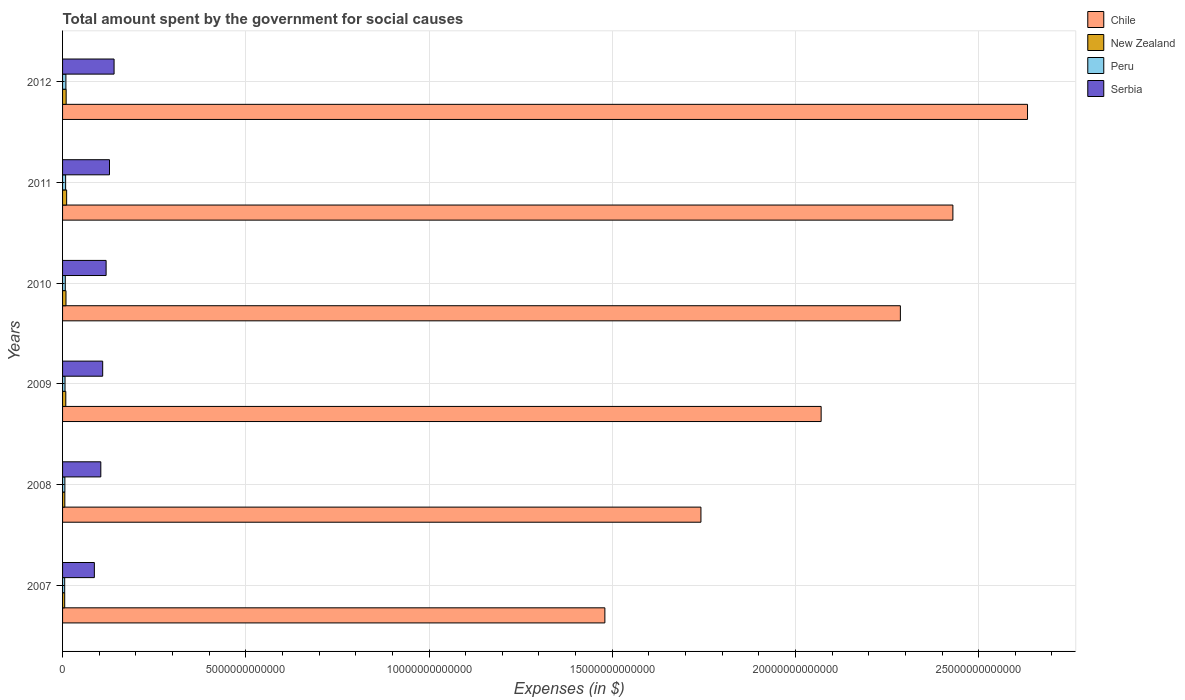How many groups of bars are there?
Ensure brevity in your answer.  6. Are the number of bars per tick equal to the number of legend labels?
Give a very brief answer. Yes. Are the number of bars on each tick of the Y-axis equal?
Your answer should be compact. Yes. How many bars are there on the 5th tick from the bottom?
Your response must be concise. 4. In how many cases, is the number of bars for a given year not equal to the number of legend labels?
Ensure brevity in your answer.  0. What is the amount spent for social causes by the government in New Zealand in 2009?
Make the answer very short. 8.84e+1. Across all years, what is the maximum amount spent for social causes by the government in New Zealand?
Keep it short and to the point. 1.11e+11. Across all years, what is the minimum amount spent for social causes by the government in Serbia?
Provide a succinct answer. 8.68e+11. In which year was the amount spent for social causes by the government in Chile minimum?
Your answer should be compact. 2007. What is the total amount spent for social causes by the government in New Zealand in the graph?
Your answer should be very brief. 5.11e+11. What is the difference between the amount spent for social causes by the government in Chile in 2009 and that in 2012?
Offer a terse response. -5.63e+12. What is the difference between the amount spent for social causes by the government in Serbia in 2009 and the amount spent for social causes by the government in Peru in 2007?
Offer a terse response. 1.04e+12. What is the average amount spent for social causes by the government in Peru per year?
Make the answer very short. 7.28e+1. In the year 2012, what is the difference between the amount spent for social causes by the government in Chile and amount spent for social causes by the government in Serbia?
Provide a succinct answer. 2.49e+13. What is the ratio of the amount spent for social causes by the government in Chile in 2007 to that in 2012?
Give a very brief answer. 0.56. Is the amount spent for social causes by the government in Peru in 2007 less than that in 2011?
Your response must be concise. Yes. What is the difference between the highest and the second highest amount spent for social causes by the government in Peru?
Give a very brief answer. 7.68e+09. What is the difference between the highest and the lowest amount spent for social causes by the government in Chile?
Your answer should be compact. 1.15e+13. In how many years, is the amount spent for social causes by the government in Chile greater than the average amount spent for social causes by the government in Chile taken over all years?
Provide a short and direct response. 3. Is it the case that in every year, the sum of the amount spent for social causes by the government in Chile and amount spent for social causes by the government in New Zealand is greater than the sum of amount spent for social causes by the government in Serbia and amount spent for social causes by the government in Peru?
Keep it short and to the point. Yes. Are all the bars in the graph horizontal?
Your answer should be very brief. Yes. How many years are there in the graph?
Your response must be concise. 6. What is the difference between two consecutive major ticks on the X-axis?
Make the answer very short. 5.00e+12. Does the graph contain grids?
Give a very brief answer. Yes. How are the legend labels stacked?
Provide a succinct answer. Vertical. What is the title of the graph?
Offer a terse response. Total amount spent by the government for social causes. What is the label or title of the X-axis?
Provide a short and direct response. Expenses (in $). What is the label or title of the Y-axis?
Your answer should be compact. Years. What is the Expenses (in $) in Chile in 2007?
Your answer should be compact. 1.48e+13. What is the Expenses (in $) of New Zealand in 2007?
Ensure brevity in your answer.  5.84e+1. What is the Expenses (in $) of Peru in 2007?
Provide a short and direct response. 5.80e+1. What is the Expenses (in $) of Serbia in 2007?
Keep it short and to the point. 8.68e+11. What is the Expenses (in $) of Chile in 2008?
Your response must be concise. 1.74e+13. What is the Expenses (in $) in New Zealand in 2008?
Your answer should be very brief. 6.18e+1. What is the Expenses (in $) of Peru in 2008?
Offer a very short reply. 6.29e+1. What is the Expenses (in $) of Serbia in 2008?
Offer a very short reply. 1.04e+12. What is the Expenses (in $) in Chile in 2009?
Your answer should be very brief. 2.07e+13. What is the Expenses (in $) of New Zealand in 2009?
Give a very brief answer. 8.84e+1. What is the Expenses (in $) in Peru in 2009?
Offer a very short reply. 6.73e+1. What is the Expenses (in $) in Serbia in 2009?
Provide a short and direct response. 1.10e+12. What is the Expenses (in $) in Chile in 2010?
Your answer should be compact. 2.29e+13. What is the Expenses (in $) of New Zealand in 2010?
Your response must be concise. 9.33e+1. What is the Expenses (in $) in Peru in 2010?
Keep it short and to the point. 7.43e+1. What is the Expenses (in $) in Serbia in 2010?
Your answer should be very brief. 1.19e+12. What is the Expenses (in $) in Chile in 2011?
Your response must be concise. 2.43e+13. What is the Expenses (in $) in New Zealand in 2011?
Make the answer very short. 1.11e+11. What is the Expenses (in $) of Peru in 2011?
Your answer should be compact. 8.34e+1. What is the Expenses (in $) in Serbia in 2011?
Offer a very short reply. 1.28e+12. What is the Expenses (in $) of Chile in 2012?
Provide a short and direct response. 2.63e+13. What is the Expenses (in $) in New Zealand in 2012?
Provide a succinct answer. 9.80e+1. What is the Expenses (in $) in Peru in 2012?
Your answer should be very brief. 9.11e+1. What is the Expenses (in $) of Serbia in 2012?
Give a very brief answer. 1.41e+12. Across all years, what is the maximum Expenses (in $) of Chile?
Provide a short and direct response. 2.63e+13. Across all years, what is the maximum Expenses (in $) in New Zealand?
Your answer should be compact. 1.11e+11. Across all years, what is the maximum Expenses (in $) in Peru?
Make the answer very short. 9.11e+1. Across all years, what is the maximum Expenses (in $) in Serbia?
Your answer should be very brief. 1.41e+12. Across all years, what is the minimum Expenses (in $) of Chile?
Your answer should be compact. 1.48e+13. Across all years, what is the minimum Expenses (in $) of New Zealand?
Provide a succinct answer. 5.84e+1. Across all years, what is the minimum Expenses (in $) of Peru?
Keep it short and to the point. 5.80e+1. Across all years, what is the minimum Expenses (in $) in Serbia?
Give a very brief answer. 8.68e+11. What is the total Expenses (in $) in Chile in the graph?
Your answer should be compact. 1.26e+14. What is the total Expenses (in $) of New Zealand in the graph?
Your answer should be compact. 5.11e+11. What is the total Expenses (in $) in Peru in the graph?
Provide a succinct answer. 4.37e+11. What is the total Expenses (in $) of Serbia in the graph?
Give a very brief answer. 6.88e+12. What is the difference between the Expenses (in $) in Chile in 2007 and that in 2008?
Provide a short and direct response. -2.62e+12. What is the difference between the Expenses (in $) in New Zealand in 2007 and that in 2008?
Your answer should be very brief. -3.37e+09. What is the difference between the Expenses (in $) of Peru in 2007 and that in 2008?
Provide a short and direct response. -4.86e+09. What is the difference between the Expenses (in $) in Serbia in 2007 and that in 2008?
Keep it short and to the point. -1.76e+11. What is the difference between the Expenses (in $) in Chile in 2007 and that in 2009?
Give a very brief answer. -5.90e+12. What is the difference between the Expenses (in $) in New Zealand in 2007 and that in 2009?
Ensure brevity in your answer.  -2.99e+1. What is the difference between the Expenses (in $) of Peru in 2007 and that in 2009?
Offer a terse response. -9.27e+09. What is the difference between the Expenses (in $) of Serbia in 2007 and that in 2009?
Provide a short and direct response. -2.27e+11. What is the difference between the Expenses (in $) in Chile in 2007 and that in 2010?
Provide a short and direct response. -8.06e+12. What is the difference between the Expenses (in $) of New Zealand in 2007 and that in 2010?
Give a very brief answer. -3.48e+1. What is the difference between the Expenses (in $) of Peru in 2007 and that in 2010?
Offer a terse response. -1.63e+1. What is the difference between the Expenses (in $) of Serbia in 2007 and that in 2010?
Your answer should be compact. -3.21e+11. What is the difference between the Expenses (in $) of Chile in 2007 and that in 2011?
Ensure brevity in your answer.  -9.50e+12. What is the difference between the Expenses (in $) in New Zealand in 2007 and that in 2011?
Your answer should be compact. -5.26e+1. What is the difference between the Expenses (in $) in Peru in 2007 and that in 2011?
Offer a terse response. -2.54e+1. What is the difference between the Expenses (in $) in Serbia in 2007 and that in 2011?
Give a very brief answer. -4.13e+11. What is the difference between the Expenses (in $) in Chile in 2007 and that in 2012?
Provide a short and direct response. -1.15e+13. What is the difference between the Expenses (in $) of New Zealand in 2007 and that in 2012?
Offer a very short reply. -3.96e+1. What is the difference between the Expenses (in $) of Peru in 2007 and that in 2012?
Your response must be concise. -3.31e+1. What is the difference between the Expenses (in $) of Serbia in 2007 and that in 2012?
Keep it short and to the point. -5.38e+11. What is the difference between the Expenses (in $) in Chile in 2008 and that in 2009?
Your response must be concise. -3.28e+12. What is the difference between the Expenses (in $) of New Zealand in 2008 and that in 2009?
Offer a terse response. -2.65e+1. What is the difference between the Expenses (in $) in Peru in 2008 and that in 2009?
Offer a terse response. -4.41e+09. What is the difference between the Expenses (in $) in Serbia in 2008 and that in 2009?
Give a very brief answer. -5.15e+1. What is the difference between the Expenses (in $) in Chile in 2008 and that in 2010?
Make the answer very short. -5.44e+12. What is the difference between the Expenses (in $) of New Zealand in 2008 and that in 2010?
Your answer should be very brief. -3.15e+1. What is the difference between the Expenses (in $) of Peru in 2008 and that in 2010?
Your answer should be compact. -1.14e+1. What is the difference between the Expenses (in $) of Serbia in 2008 and that in 2010?
Give a very brief answer. -1.45e+11. What is the difference between the Expenses (in $) in Chile in 2008 and that in 2011?
Make the answer very short. -6.88e+12. What is the difference between the Expenses (in $) in New Zealand in 2008 and that in 2011?
Make the answer very short. -4.92e+1. What is the difference between the Expenses (in $) of Peru in 2008 and that in 2011?
Provide a succinct answer. -2.05e+1. What is the difference between the Expenses (in $) of Serbia in 2008 and that in 2011?
Give a very brief answer. -2.37e+11. What is the difference between the Expenses (in $) in Chile in 2008 and that in 2012?
Ensure brevity in your answer.  -8.91e+12. What is the difference between the Expenses (in $) in New Zealand in 2008 and that in 2012?
Your response must be concise. -3.62e+1. What is the difference between the Expenses (in $) of Peru in 2008 and that in 2012?
Your answer should be very brief. -2.82e+1. What is the difference between the Expenses (in $) in Serbia in 2008 and that in 2012?
Ensure brevity in your answer.  -3.62e+11. What is the difference between the Expenses (in $) in Chile in 2009 and that in 2010?
Your answer should be compact. -2.16e+12. What is the difference between the Expenses (in $) of New Zealand in 2009 and that in 2010?
Provide a short and direct response. -4.93e+09. What is the difference between the Expenses (in $) of Peru in 2009 and that in 2010?
Ensure brevity in your answer.  -7.01e+09. What is the difference between the Expenses (in $) of Serbia in 2009 and that in 2010?
Provide a succinct answer. -9.34e+1. What is the difference between the Expenses (in $) of Chile in 2009 and that in 2011?
Provide a succinct answer. -3.60e+12. What is the difference between the Expenses (in $) in New Zealand in 2009 and that in 2011?
Make the answer very short. -2.27e+1. What is the difference between the Expenses (in $) of Peru in 2009 and that in 2011?
Offer a terse response. -1.61e+1. What is the difference between the Expenses (in $) of Serbia in 2009 and that in 2011?
Give a very brief answer. -1.86e+11. What is the difference between the Expenses (in $) of Chile in 2009 and that in 2012?
Give a very brief answer. -5.63e+12. What is the difference between the Expenses (in $) of New Zealand in 2009 and that in 2012?
Offer a terse response. -9.65e+09. What is the difference between the Expenses (in $) of Peru in 2009 and that in 2012?
Ensure brevity in your answer.  -2.38e+1. What is the difference between the Expenses (in $) of Serbia in 2009 and that in 2012?
Provide a short and direct response. -3.11e+11. What is the difference between the Expenses (in $) of Chile in 2010 and that in 2011?
Give a very brief answer. -1.43e+12. What is the difference between the Expenses (in $) of New Zealand in 2010 and that in 2011?
Offer a terse response. -1.77e+1. What is the difference between the Expenses (in $) in Peru in 2010 and that in 2011?
Your answer should be compact. -9.12e+09. What is the difference between the Expenses (in $) in Serbia in 2010 and that in 2011?
Provide a succinct answer. -9.25e+1. What is the difference between the Expenses (in $) of Chile in 2010 and that in 2012?
Offer a very short reply. -3.47e+12. What is the difference between the Expenses (in $) of New Zealand in 2010 and that in 2012?
Provide a short and direct response. -4.72e+09. What is the difference between the Expenses (in $) in Peru in 2010 and that in 2012?
Give a very brief answer. -1.68e+1. What is the difference between the Expenses (in $) in Serbia in 2010 and that in 2012?
Offer a very short reply. -2.17e+11. What is the difference between the Expenses (in $) in Chile in 2011 and that in 2012?
Your response must be concise. -2.04e+12. What is the difference between the Expenses (in $) of New Zealand in 2011 and that in 2012?
Make the answer very short. 1.30e+1. What is the difference between the Expenses (in $) of Peru in 2011 and that in 2012?
Offer a very short reply. -7.68e+09. What is the difference between the Expenses (in $) of Serbia in 2011 and that in 2012?
Keep it short and to the point. -1.25e+11. What is the difference between the Expenses (in $) in Chile in 2007 and the Expenses (in $) in New Zealand in 2008?
Provide a short and direct response. 1.47e+13. What is the difference between the Expenses (in $) in Chile in 2007 and the Expenses (in $) in Peru in 2008?
Ensure brevity in your answer.  1.47e+13. What is the difference between the Expenses (in $) of Chile in 2007 and the Expenses (in $) of Serbia in 2008?
Make the answer very short. 1.38e+13. What is the difference between the Expenses (in $) in New Zealand in 2007 and the Expenses (in $) in Peru in 2008?
Give a very brief answer. -4.42e+09. What is the difference between the Expenses (in $) of New Zealand in 2007 and the Expenses (in $) of Serbia in 2008?
Provide a succinct answer. -9.85e+11. What is the difference between the Expenses (in $) of Peru in 2007 and the Expenses (in $) of Serbia in 2008?
Your answer should be very brief. -9.86e+11. What is the difference between the Expenses (in $) of Chile in 2007 and the Expenses (in $) of New Zealand in 2009?
Your response must be concise. 1.47e+13. What is the difference between the Expenses (in $) in Chile in 2007 and the Expenses (in $) in Peru in 2009?
Provide a succinct answer. 1.47e+13. What is the difference between the Expenses (in $) in Chile in 2007 and the Expenses (in $) in Serbia in 2009?
Your answer should be compact. 1.37e+13. What is the difference between the Expenses (in $) in New Zealand in 2007 and the Expenses (in $) in Peru in 2009?
Your answer should be compact. -8.82e+09. What is the difference between the Expenses (in $) in New Zealand in 2007 and the Expenses (in $) in Serbia in 2009?
Give a very brief answer. -1.04e+12. What is the difference between the Expenses (in $) of Peru in 2007 and the Expenses (in $) of Serbia in 2009?
Make the answer very short. -1.04e+12. What is the difference between the Expenses (in $) of Chile in 2007 and the Expenses (in $) of New Zealand in 2010?
Your answer should be very brief. 1.47e+13. What is the difference between the Expenses (in $) of Chile in 2007 and the Expenses (in $) of Peru in 2010?
Ensure brevity in your answer.  1.47e+13. What is the difference between the Expenses (in $) of Chile in 2007 and the Expenses (in $) of Serbia in 2010?
Offer a terse response. 1.36e+13. What is the difference between the Expenses (in $) of New Zealand in 2007 and the Expenses (in $) of Peru in 2010?
Offer a terse response. -1.58e+1. What is the difference between the Expenses (in $) of New Zealand in 2007 and the Expenses (in $) of Serbia in 2010?
Your answer should be very brief. -1.13e+12. What is the difference between the Expenses (in $) in Peru in 2007 and the Expenses (in $) in Serbia in 2010?
Offer a very short reply. -1.13e+12. What is the difference between the Expenses (in $) in Chile in 2007 and the Expenses (in $) in New Zealand in 2011?
Make the answer very short. 1.47e+13. What is the difference between the Expenses (in $) in Chile in 2007 and the Expenses (in $) in Peru in 2011?
Make the answer very short. 1.47e+13. What is the difference between the Expenses (in $) in Chile in 2007 and the Expenses (in $) in Serbia in 2011?
Keep it short and to the point. 1.35e+13. What is the difference between the Expenses (in $) in New Zealand in 2007 and the Expenses (in $) in Peru in 2011?
Your answer should be very brief. -2.50e+1. What is the difference between the Expenses (in $) of New Zealand in 2007 and the Expenses (in $) of Serbia in 2011?
Your response must be concise. -1.22e+12. What is the difference between the Expenses (in $) in Peru in 2007 and the Expenses (in $) in Serbia in 2011?
Provide a short and direct response. -1.22e+12. What is the difference between the Expenses (in $) in Chile in 2007 and the Expenses (in $) in New Zealand in 2012?
Your response must be concise. 1.47e+13. What is the difference between the Expenses (in $) of Chile in 2007 and the Expenses (in $) of Peru in 2012?
Your answer should be compact. 1.47e+13. What is the difference between the Expenses (in $) in Chile in 2007 and the Expenses (in $) in Serbia in 2012?
Offer a very short reply. 1.34e+13. What is the difference between the Expenses (in $) of New Zealand in 2007 and the Expenses (in $) of Peru in 2012?
Offer a terse response. -3.26e+1. What is the difference between the Expenses (in $) in New Zealand in 2007 and the Expenses (in $) in Serbia in 2012?
Your answer should be compact. -1.35e+12. What is the difference between the Expenses (in $) in Peru in 2007 and the Expenses (in $) in Serbia in 2012?
Give a very brief answer. -1.35e+12. What is the difference between the Expenses (in $) of Chile in 2008 and the Expenses (in $) of New Zealand in 2009?
Offer a terse response. 1.73e+13. What is the difference between the Expenses (in $) of Chile in 2008 and the Expenses (in $) of Peru in 2009?
Your answer should be very brief. 1.74e+13. What is the difference between the Expenses (in $) in Chile in 2008 and the Expenses (in $) in Serbia in 2009?
Offer a very short reply. 1.63e+13. What is the difference between the Expenses (in $) in New Zealand in 2008 and the Expenses (in $) in Peru in 2009?
Make the answer very short. -5.46e+09. What is the difference between the Expenses (in $) in New Zealand in 2008 and the Expenses (in $) in Serbia in 2009?
Provide a succinct answer. -1.03e+12. What is the difference between the Expenses (in $) in Peru in 2008 and the Expenses (in $) in Serbia in 2009?
Ensure brevity in your answer.  -1.03e+12. What is the difference between the Expenses (in $) of Chile in 2008 and the Expenses (in $) of New Zealand in 2010?
Ensure brevity in your answer.  1.73e+13. What is the difference between the Expenses (in $) in Chile in 2008 and the Expenses (in $) in Peru in 2010?
Your answer should be compact. 1.73e+13. What is the difference between the Expenses (in $) in Chile in 2008 and the Expenses (in $) in Serbia in 2010?
Offer a very short reply. 1.62e+13. What is the difference between the Expenses (in $) of New Zealand in 2008 and the Expenses (in $) of Peru in 2010?
Provide a succinct answer. -1.25e+1. What is the difference between the Expenses (in $) of New Zealand in 2008 and the Expenses (in $) of Serbia in 2010?
Your answer should be compact. -1.13e+12. What is the difference between the Expenses (in $) of Peru in 2008 and the Expenses (in $) of Serbia in 2010?
Your response must be concise. -1.13e+12. What is the difference between the Expenses (in $) in Chile in 2008 and the Expenses (in $) in New Zealand in 2011?
Provide a short and direct response. 1.73e+13. What is the difference between the Expenses (in $) of Chile in 2008 and the Expenses (in $) of Peru in 2011?
Your answer should be very brief. 1.73e+13. What is the difference between the Expenses (in $) of Chile in 2008 and the Expenses (in $) of Serbia in 2011?
Offer a terse response. 1.61e+13. What is the difference between the Expenses (in $) of New Zealand in 2008 and the Expenses (in $) of Peru in 2011?
Provide a succinct answer. -2.16e+1. What is the difference between the Expenses (in $) of New Zealand in 2008 and the Expenses (in $) of Serbia in 2011?
Ensure brevity in your answer.  -1.22e+12. What is the difference between the Expenses (in $) of Peru in 2008 and the Expenses (in $) of Serbia in 2011?
Your answer should be compact. -1.22e+12. What is the difference between the Expenses (in $) of Chile in 2008 and the Expenses (in $) of New Zealand in 2012?
Provide a short and direct response. 1.73e+13. What is the difference between the Expenses (in $) in Chile in 2008 and the Expenses (in $) in Peru in 2012?
Give a very brief answer. 1.73e+13. What is the difference between the Expenses (in $) of Chile in 2008 and the Expenses (in $) of Serbia in 2012?
Ensure brevity in your answer.  1.60e+13. What is the difference between the Expenses (in $) of New Zealand in 2008 and the Expenses (in $) of Peru in 2012?
Offer a very short reply. -2.93e+1. What is the difference between the Expenses (in $) of New Zealand in 2008 and the Expenses (in $) of Serbia in 2012?
Your answer should be compact. -1.34e+12. What is the difference between the Expenses (in $) of Peru in 2008 and the Expenses (in $) of Serbia in 2012?
Keep it short and to the point. -1.34e+12. What is the difference between the Expenses (in $) in Chile in 2009 and the Expenses (in $) in New Zealand in 2010?
Provide a succinct answer. 2.06e+13. What is the difference between the Expenses (in $) in Chile in 2009 and the Expenses (in $) in Peru in 2010?
Your answer should be very brief. 2.06e+13. What is the difference between the Expenses (in $) in Chile in 2009 and the Expenses (in $) in Serbia in 2010?
Make the answer very short. 1.95e+13. What is the difference between the Expenses (in $) in New Zealand in 2009 and the Expenses (in $) in Peru in 2010?
Your response must be concise. 1.41e+1. What is the difference between the Expenses (in $) of New Zealand in 2009 and the Expenses (in $) of Serbia in 2010?
Offer a terse response. -1.10e+12. What is the difference between the Expenses (in $) of Peru in 2009 and the Expenses (in $) of Serbia in 2010?
Provide a succinct answer. -1.12e+12. What is the difference between the Expenses (in $) of Chile in 2009 and the Expenses (in $) of New Zealand in 2011?
Ensure brevity in your answer.  2.06e+13. What is the difference between the Expenses (in $) of Chile in 2009 and the Expenses (in $) of Peru in 2011?
Your response must be concise. 2.06e+13. What is the difference between the Expenses (in $) in Chile in 2009 and the Expenses (in $) in Serbia in 2011?
Provide a short and direct response. 1.94e+13. What is the difference between the Expenses (in $) in New Zealand in 2009 and the Expenses (in $) in Peru in 2011?
Your response must be concise. 4.96e+09. What is the difference between the Expenses (in $) of New Zealand in 2009 and the Expenses (in $) of Serbia in 2011?
Offer a terse response. -1.19e+12. What is the difference between the Expenses (in $) in Peru in 2009 and the Expenses (in $) in Serbia in 2011?
Your answer should be very brief. -1.21e+12. What is the difference between the Expenses (in $) in Chile in 2009 and the Expenses (in $) in New Zealand in 2012?
Keep it short and to the point. 2.06e+13. What is the difference between the Expenses (in $) of Chile in 2009 and the Expenses (in $) of Peru in 2012?
Keep it short and to the point. 2.06e+13. What is the difference between the Expenses (in $) of Chile in 2009 and the Expenses (in $) of Serbia in 2012?
Offer a terse response. 1.93e+13. What is the difference between the Expenses (in $) of New Zealand in 2009 and the Expenses (in $) of Peru in 2012?
Your answer should be very brief. -2.73e+09. What is the difference between the Expenses (in $) of New Zealand in 2009 and the Expenses (in $) of Serbia in 2012?
Provide a short and direct response. -1.32e+12. What is the difference between the Expenses (in $) in Peru in 2009 and the Expenses (in $) in Serbia in 2012?
Keep it short and to the point. -1.34e+12. What is the difference between the Expenses (in $) of Chile in 2010 and the Expenses (in $) of New Zealand in 2011?
Offer a terse response. 2.28e+13. What is the difference between the Expenses (in $) of Chile in 2010 and the Expenses (in $) of Peru in 2011?
Your answer should be very brief. 2.28e+13. What is the difference between the Expenses (in $) in Chile in 2010 and the Expenses (in $) in Serbia in 2011?
Give a very brief answer. 2.16e+13. What is the difference between the Expenses (in $) in New Zealand in 2010 and the Expenses (in $) in Peru in 2011?
Offer a very short reply. 9.89e+09. What is the difference between the Expenses (in $) of New Zealand in 2010 and the Expenses (in $) of Serbia in 2011?
Offer a very short reply. -1.19e+12. What is the difference between the Expenses (in $) in Peru in 2010 and the Expenses (in $) in Serbia in 2011?
Make the answer very short. -1.21e+12. What is the difference between the Expenses (in $) in Chile in 2010 and the Expenses (in $) in New Zealand in 2012?
Make the answer very short. 2.28e+13. What is the difference between the Expenses (in $) of Chile in 2010 and the Expenses (in $) of Peru in 2012?
Your answer should be very brief. 2.28e+13. What is the difference between the Expenses (in $) in Chile in 2010 and the Expenses (in $) in Serbia in 2012?
Your answer should be compact. 2.15e+13. What is the difference between the Expenses (in $) of New Zealand in 2010 and the Expenses (in $) of Peru in 2012?
Provide a short and direct response. 2.20e+09. What is the difference between the Expenses (in $) in New Zealand in 2010 and the Expenses (in $) in Serbia in 2012?
Keep it short and to the point. -1.31e+12. What is the difference between the Expenses (in $) in Peru in 2010 and the Expenses (in $) in Serbia in 2012?
Your answer should be very brief. -1.33e+12. What is the difference between the Expenses (in $) of Chile in 2011 and the Expenses (in $) of New Zealand in 2012?
Your answer should be very brief. 2.42e+13. What is the difference between the Expenses (in $) in Chile in 2011 and the Expenses (in $) in Peru in 2012?
Keep it short and to the point. 2.42e+13. What is the difference between the Expenses (in $) of Chile in 2011 and the Expenses (in $) of Serbia in 2012?
Your response must be concise. 2.29e+13. What is the difference between the Expenses (in $) of New Zealand in 2011 and the Expenses (in $) of Peru in 2012?
Your answer should be compact. 1.99e+1. What is the difference between the Expenses (in $) of New Zealand in 2011 and the Expenses (in $) of Serbia in 2012?
Ensure brevity in your answer.  -1.29e+12. What is the difference between the Expenses (in $) in Peru in 2011 and the Expenses (in $) in Serbia in 2012?
Make the answer very short. -1.32e+12. What is the average Expenses (in $) of Chile per year?
Ensure brevity in your answer.  2.11e+13. What is the average Expenses (in $) in New Zealand per year?
Ensure brevity in your answer.  8.52e+1. What is the average Expenses (in $) of Peru per year?
Your answer should be very brief. 7.28e+1. What is the average Expenses (in $) in Serbia per year?
Make the answer very short. 1.15e+12. In the year 2007, what is the difference between the Expenses (in $) in Chile and Expenses (in $) in New Zealand?
Make the answer very short. 1.47e+13. In the year 2007, what is the difference between the Expenses (in $) in Chile and Expenses (in $) in Peru?
Ensure brevity in your answer.  1.47e+13. In the year 2007, what is the difference between the Expenses (in $) in Chile and Expenses (in $) in Serbia?
Offer a very short reply. 1.39e+13. In the year 2007, what is the difference between the Expenses (in $) in New Zealand and Expenses (in $) in Peru?
Give a very brief answer. 4.45e+08. In the year 2007, what is the difference between the Expenses (in $) of New Zealand and Expenses (in $) of Serbia?
Provide a short and direct response. -8.09e+11. In the year 2007, what is the difference between the Expenses (in $) of Peru and Expenses (in $) of Serbia?
Provide a succinct answer. -8.10e+11. In the year 2008, what is the difference between the Expenses (in $) in Chile and Expenses (in $) in New Zealand?
Your response must be concise. 1.74e+13. In the year 2008, what is the difference between the Expenses (in $) in Chile and Expenses (in $) in Peru?
Provide a short and direct response. 1.74e+13. In the year 2008, what is the difference between the Expenses (in $) in Chile and Expenses (in $) in Serbia?
Ensure brevity in your answer.  1.64e+13. In the year 2008, what is the difference between the Expenses (in $) in New Zealand and Expenses (in $) in Peru?
Your answer should be compact. -1.05e+09. In the year 2008, what is the difference between the Expenses (in $) of New Zealand and Expenses (in $) of Serbia?
Your response must be concise. -9.82e+11. In the year 2008, what is the difference between the Expenses (in $) in Peru and Expenses (in $) in Serbia?
Keep it short and to the point. -9.81e+11. In the year 2009, what is the difference between the Expenses (in $) in Chile and Expenses (in $) in New Zealand?
Keep it short and to the point. 2.06e+13. In the year 2009, what is the difference between the Expenses (in $) in Chile and Expenses (in $) in Peru?
Provide a short and direct response. 2.06e+13. In the year 2009, what is the difference between the Expenses (in $) of Chile and Expenses (in $) of Serbia?
Provide a short and direct response. 1.96e+13. In the year 2009, what is the difference between the Expenses (in $) of New Zealand and Expenses (in $) of Peru?
Give a very brief answer. 2.11e+1. In the year 2009, what is the difference between the Expenses (in $) in New Zealand and Expenses (in $) in Serbia?
Provide a short and direct response. -1.01e+12. In the year 2009, what is the difference between the Expenses (in $) of Peru and Expenses (in $) of Serbia?
Make the answer very short. -1.03e+12. In the year 2010, what is the difference between the Expenses (in $) of Chile and Expenses (in $) of New Zealand?
Provide a short and direct response. 2.28e+13. In the year 2010, what is the difference between the Expenses (in $) of Chile and Expenses (in $) of Peru?
Your response must be concise. 2.28e+13. In the year 2010, what is the difference between the Expenses (in $) in Chile and Expenses (in $) in Serbia?
Your answer should be compact. 2.17e+13. In the year 2010, what is the difference between the Expenses (in $) of New Zealand and Expenses (in $) of Peru?
Give a very brief answer. 1.90e+1. In the year 2010, what is the difference between the Expenses (in $) in New Zealand and Expenses (in $) in Serbia?
Keep it short and to the point. -1.10e+12. In the year 2010, what is the difference between the Expenses (in $) in Peru and Expenses (in $) in Serbia?
Make the answer very short. -1.11e+12. In the year 2011, what is the difference between the Expenses (in $) of Chile and Expenses (in $) of New Zealand?
Your response must be concise. 2.42e+13. In the year 2011, what is the difference between the Expenses (in $) of Chile and Expenses (in $) of Peru?
Ensure brevity in your answer.  2.42e+13. In the year 2011, what is the difference between the Expenses (in $) in Chile and Expenses (in $) in Serbia?
Your response must be concise. 2.30e+13. In the year 2011, what is the difference between the Expenses (in $) of New Zealand and Expenses (in $) of Peru?
Your answer should be compact. 2.76e+1. In the year 2011, what is the difference between the Expenses (in $) of New Zealand and Expenses (in $) of Serbia?
Offer a terse response. -1.17e+12. In the year 2011, what is the difference between the Expenses (in $) in Peru and Expenses (in $) in Serbia?
Your response must be concise. -1.20e+12. In the year 2012, what is the difference between the Expenses (in $) in Chile and Expenses (in $) in New Zealand?
Give a very brief answer. 2.62e+13. In the year 2012, what is the difference between the Expenses (in $) of Chile and Expenses (in $) of Peru?
Your response must be concise. 2.62e+13. In the year 2012, what is the difference between the Expenses (in $) of Chile and Expenses (in $) of Serbia?
Offer a terse response. 2.49e+13. In the year 2012, what is the difference between the Expenses (in $) in New Zealand and Expenses (in $) in Peru?
Your answer should be compact. 6.93e+09. In the year 2012, what is the difference between the Expenses (in $) of New Zealand and Expenses (in $) of Serbia?
Your answer should be compact. -1.31e+12. In the year 2012, what is the difference between the Expenses (in $) in Peru and Expenses (in $) in Serbia?
Your answer should be compact. -1.31e+12. What is the ratio of the Expenses (in $) in Chile in 2007 to that in 2008?
Your answer should be very brief. 0.85. What is the ratio of the Expenses (in $) in New Zealand in 2007 to that in 2008?
Your answer should be compact. 0.95. What is the ratio of the Expenses (in $) in Peru in 2007 to that in 2008?
Make the answer very short. 0.92. What is the ratio of the Expenses (in $) in Serbia in 2007 to that in 2008?
Offer a very short reply. 0.83. What is the ratio of the Expenses (in $) of Chile in 2007 to that in 2009?
Offer a very short reply. 0.71. What is the ratio of the Expenses (in $) of New Zealand in 2007 to that in 2009?
Your answer should be compact. 0.66. What is the ratio of the Expenses (in $) in Peru in 2007 to that in 2009?
Make the answer very short. 0.86. What is the ratio of the Expenses (in $) of Serbia in 2007 to that in 2009?
Your answer should be very brief. 0.79. What is the ratio of the Expenses (in $) of Chile in 2007 to that in 2010?
Provide a short and direct response. 0.65. What is the ratio of the Expenses (in $) in New Zealand in 2007 to that in 2010?
Offer a very short reply. 0.63. What is the ratio of the Expenses (in $) in Peru in 2007 to that in 2010?
Your answer should be compact. 0.78. What is the ratio of the Expenses (in $) of Serbia in 2007 to that in 2010?
Offer a very short reply. 0.73. What is the ratio of the Expenses (in $) of Chile in 2007 to that in 2011?
Provide a short and direct response. 0.61. What is the ratio of the Expenses (in $) of New Zealand in 2007 to that in 2011?
Your answer should be compact. 0.53. What is the ratio of the Expenses (in $) of Peru in 2007 to that in 2011?
Give a very brief answer. 0.7. What is the ratio of the Expenses (in $) in Serbia in 2007 to that in 2011?
Offer a terse response. 0.68. What is the ratio of the Expenses (in $) in Chile in 2007 to that in 2012?
Your answer should be very brief. 0.56. What is the ratio of the Expenses (in $) of New Zealand in 2007 to that in 2012?
Your response must be concise. 0.6. What is the ratio of the Expenses (in $) in Peru in 2007 to that in 2012?
Provide a short and direct response. 0.64. What is the ratio of the Expenses (in $) of Serbia in 2007 to that in 2012?
Offer a very short reply. 0.62. What is the ratio of the Expenses (in $) of Chile in 2008 to that in 2009?
Your answer should be compact. 0.84. What is the ratio of the Expenses (in $) in New Zealand in 2008 to that in 2009?
Your response must be concise. 0.7. What is the ratio of the Expenses (in $) of Peru in 2008 to that in 2009?
Your answer should be very brief. 0.93. What is the ratio of the Expenses (in $) in Serbia in 2008 to that in 2009?
Your answer should be compact. 0.95. What is the ratio of the Expenses (in $) in Chile in 2008 to that in 2010?
Keep it short and to the point. 0.76. What is the ratio of the Expenses (in $) in New Zealand in 2008 to that in 2010?
Give a very brief answer. 0.66. What is the ratio of the Expenses (in $) of Peru in 2008 to that in 2010?
Keep it short and to the point. 0.85. What is the ratio of the Expenses (in $) in Serbia in 2008 to that in 2010?
Offer a very short reply. 0.88. What is the ratio of the Expenses (in $) of Chile in 2008 to that in 2011?
Provide a short and direct response. 0.72. What is the ratio of the Expenses (in $) of New Zealand in 2008 to that in 2011?
Offer a very short reply. 0.56. What is the ratio of the Expenses (in $) of Peru in 2008 to that in 2011?
Ensure brevity in your answer.  0.75. What is the ratio of the Expenses (in $) in Serbia in 2008 to that in 2011?
Give a very brief answer. 0.81. What is the ratio of the Expenses (in $) in Chile in 2008 to that in 2012?
Provide a short and direct response. 0.66. What is the ratio of the Expenses (in $) of New Zealand in 2008 to that in 2012?
Give a very brief answer. 0.63. What is the ratio of the Expenses (in $) of Peru in 2008 to that in 2012?
Make the answer very short. 0.69. What is the ratio of the Expenses (in $) of Serbia in 2008 to that in 2012?
Make the answer very short. 0.74. What is the ratio of the Expenses (in $) of Chile in 2009 to that in 2010?
Keep it short and to the point. 0.91. What is the ratio of the Expenses (in $) in New Zealand in 2009 to that in 2010?
Offer a very short reply. 0.95. What is the ratio of the Expenses (in $) in Peru in 2009 to that in 2010?
Offer a terse response. 0.91. What is the ratio of the Expenses (in $) in Serbia in 2009 to that in 2010?
Your response must be concise. 0.92. What is the ratio of the Expenses (in $) of Chile in 2009 to that in 2011?
Make the answer very short. 0.85. What is the ratio of the Expenses (in $) in New Zealand in 2009 to that in 2011?
Your answer should be compact. 0.8. What is the ratio of the Expenses (in $) of Peru in 2009 to that in 2011?
Your response must be concise. 0.81. What is the ratio of the Expenses (in $) of Serbia in 2009 to that in 2011?
Your answer should be very brief. 0.85. What is the ratio of the Expenses (in $) of Chile in 2009 to that in 2012?
Provide a short and direct response. 0.79. What is the ratio of the Expenses (in $) of New Zealand in 2009 to that in 2012?
Keep it short and to the point. 0.9. What is the ratio of the Expenses (in $) in Peru in 2009 to that in 2012?
Your answer should be compact. 0.74. What is the ratio of the Expenses (in $) of Serbia in 2009 to that in 2012?
Your answer should be very brief. 0.78. What is the ratio of the Expenses (in $) in Chile in 2010 to that in 2011?
Your answer should be very brief. 0.94. What is the ratio of the Expenses (in $) in New Zealand in 2010 to that in 2011?
Your answer should be compact. 0.84. What is the ratio of the Expenses (in $) of Peru in 2010 to that in 2011?
Your response must be concise. 0.89. What is the ratio of the Expenses (in $) in Serbia in 2010 to that in 2011?
Provide a succinct answer. 0.93. What is the ratio of the Expenses (in $) of Chile in 2010 to that in 2012?
Make the answer very short. 0.87. What is the ratio of the Expenses (in $) in New Zealand in 2010 to that in 2012?
Offer a very short reply. 0.95. What is the ratio of the Expenses (in $) of Peru in 2010 to that in 2012?
Make the answer very short. 0.82. What is the ratio of the Expenses (in $) in Serbia in 2010 to that in 2012?
Provide a short and direct response. 0.85. What is the ratio of the Expenses (in $) of Chile in 2011 to that in 2012?
Ensure brevity in your answer.  0.92. What is the ratio of the Expenses (in $) in New Zealand in 2011 to that in 2012?
Offer a terse response. 1.13. What is the ratio of the Expenses (in $) in Peru in 2011 to that in 2012?
Provide a short and direct response. 0.92. What is the ratio of the Expenses (in $) of Serbia in 2011 to that in 2012?
Provide a short and direct response. 0.91. What is the difference between the highest and the second highest Expenses (in $) in Chile?
Provide a short and direct response. 2.04e+12. What is the difference between the highest and the second highest Expenses (in $) in New Zealand?
Offer a very short reply. 1.30e+1. What is the difference between the highest and the second highest Expenses (in $) in Peru?
Your answer should be very brief. 7.68e+09. What is the difference between the highest and the second highest Expenses (in $) in Serbia?
Provide a short and direct response. 1.25e+11. What is the difference between the highest and the lowest Expenses (in $) of Chile?
Ensure brevity in your answer.  1.15e+13. What is the difference between the highest and the lowest Expenses (in $) of New Zealand?
Provide a short and direct response. 5.26e+1. What is the difference between the highest and the lowest Expenses (in $) of Peru?
Offer a very short reply. 3.31e+1. What is the difference between the highest and the lowest Expenses (in $) in Serbia?
Provide a succinct answer. 5.38e+11. 